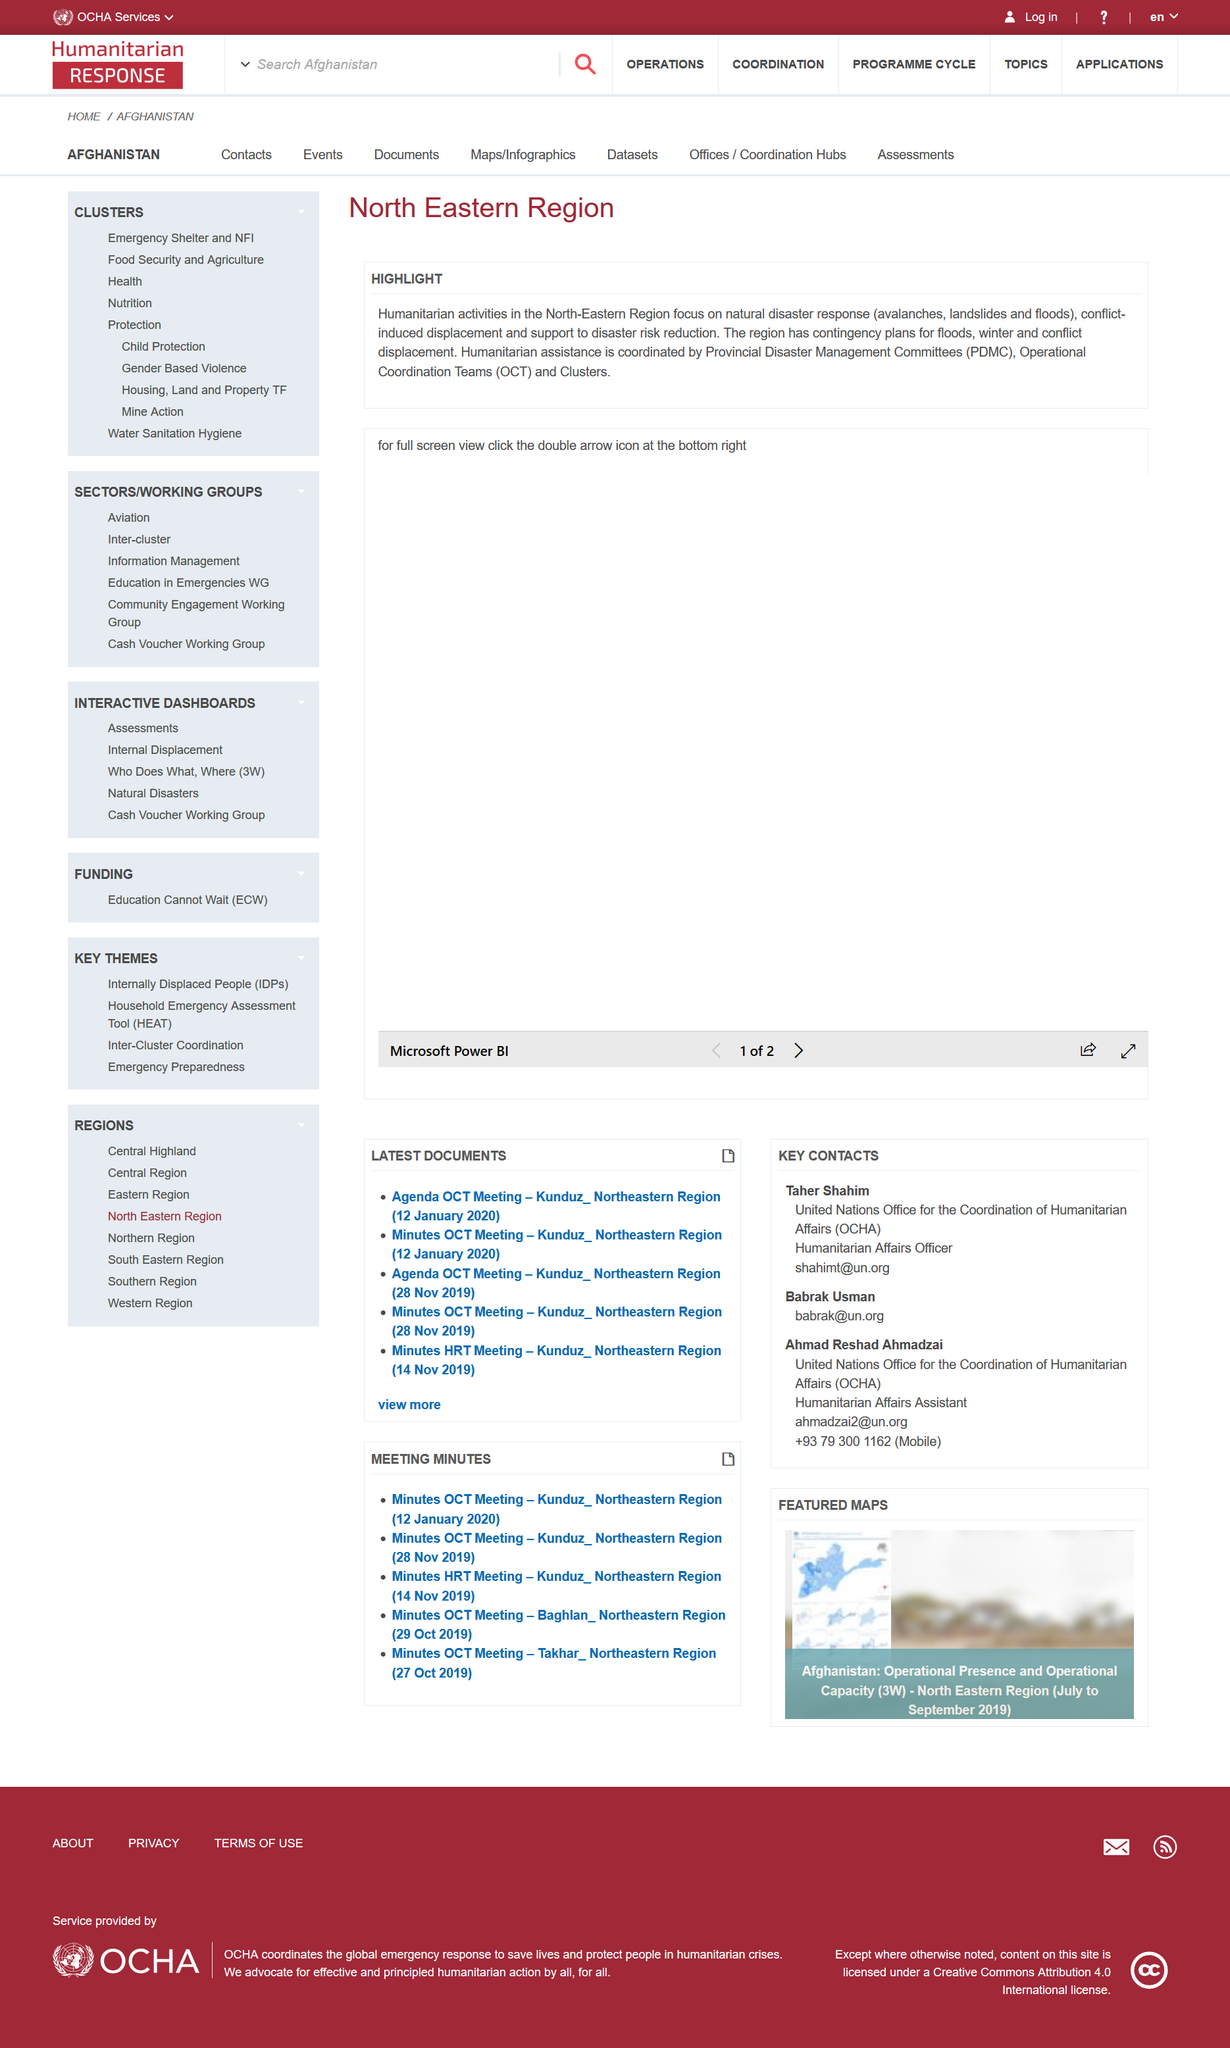Draw attention to some important aspects in this diagram. Provincial Disaster Management Committees (PDMC) is an acronym that stands for a committee responsible for managing disasters at the provincial level. Avalanches, landslides, and floods are all examples of natural disasters, which are extreme events that can cause widespread damage and loss of life. In the North Eastern region, humanitarian activities are being carried out. 